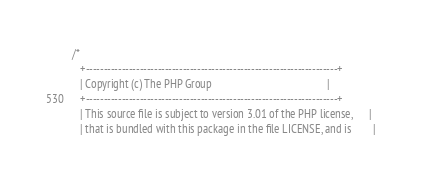<code> <loc_0><loc_0><loc_500><loc_500><_C_>/*
   +----------------------------------------------------------------------+
   | Copyright (c) The PHP Group                                          |
   +----------------------------------------------------------------------+
   | This source file is subject to version 3.01 of the PHP license,      |
   | that is bundled with this package in the file LICENSE, and is        |</code> 